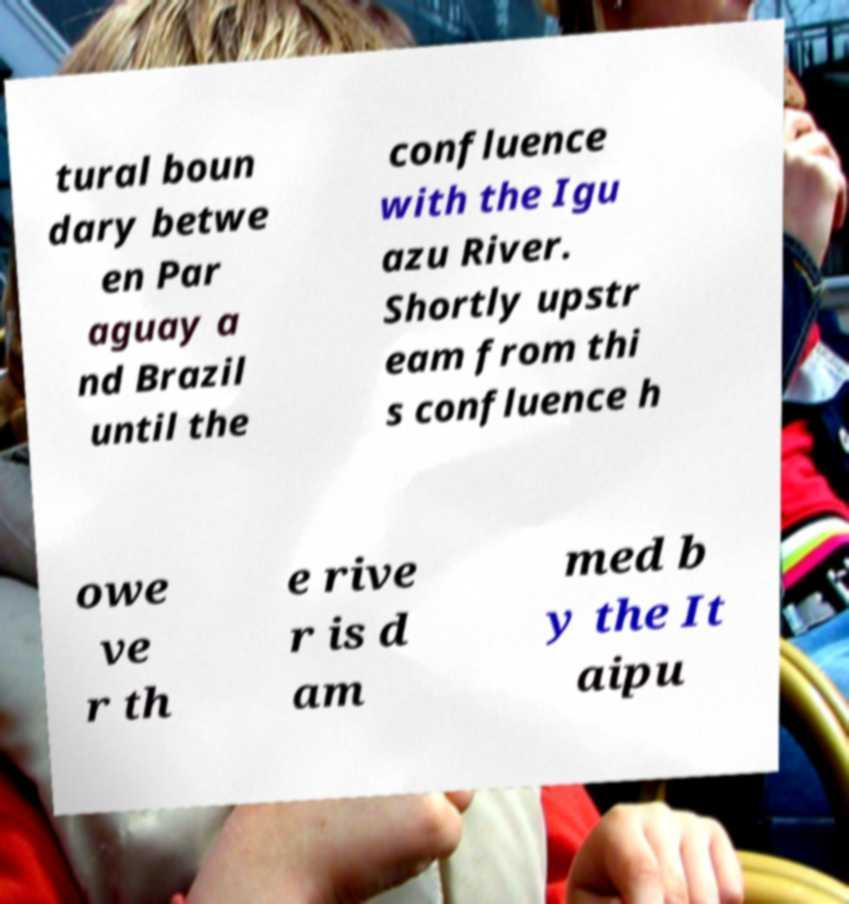There's text embedded in this image that I need extracted. Can you transcribe it verbatim? tural boun dary betwe en Par aguay a nd Brazil until the confluence with the Igu azu River. Shortly upstr eam from thi s confluence h owe ve r th e rive r is d am med b y the It aipu 